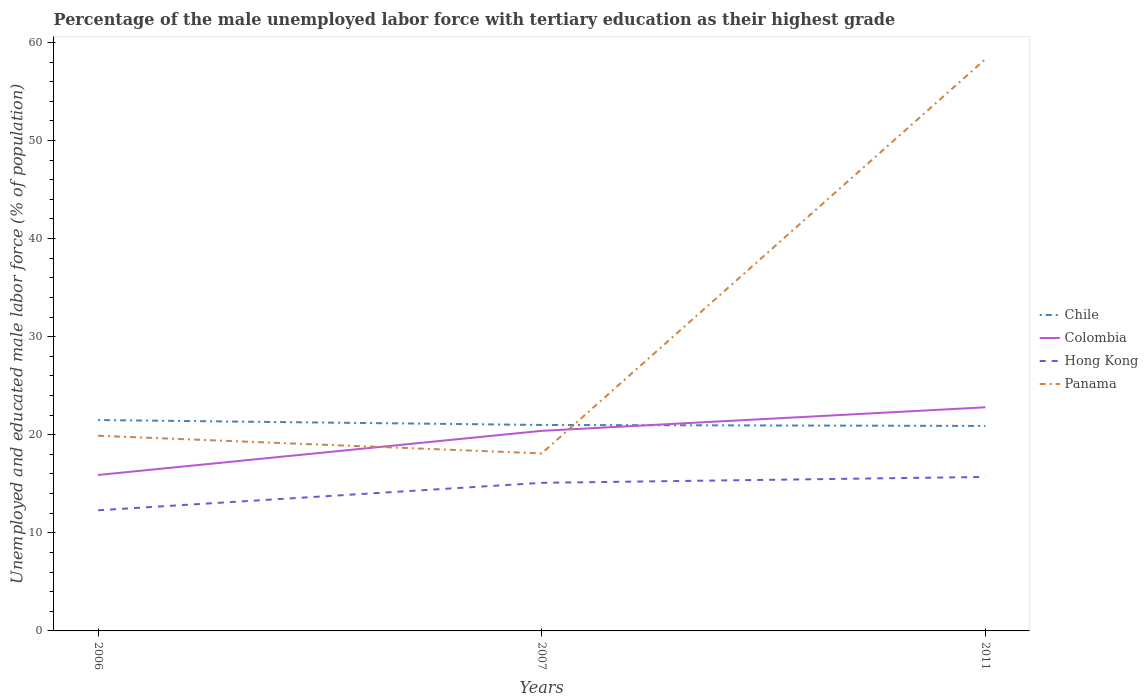Across all years, what is the maximum percentage of the unemployed male labor force with tertiary education in Panama?
Offer a terse response. 18.1. In which year was the percentage of the unemployed male labor force with tertiary education in Colombia maximum?
Provide a succinct answer. 2006. What is the total percentage of the unemployed male labor force with tertiary education in Hong Kong in the graph?
Ensure brevity in your answer.  -3.4. What is the difference between the highest and the second highest percentage of the unemployed male labor force with tertiary education in Hong Kong?
Offer a very short reply. 3.4. How many lines are there?
Provide a short and direct response. 4. What is the difference between two consecutive major ticks on the Y-axis?
Keep it short and to the point. 10. Does the graph contain any zero values?
Make the answer very short. No. How many legend labels are there?
Your response must be concise. 4. How are the legend labels stacked?
Offer a terse response. Vertical. What is the title of the graph?
Offer a terse response. Percentage of the male unemployed labor force with tertiary education as their highest grade. Does "Germany" appear as one of the legend labels in the graph?
Your answer should be compact. No. What is the label or title of the X-axis?
Ensure brevity in your answer.  Years. What is the label or title of the Y-axis?
Provide a short and direct response. Unemployed and educated male labor force (% of population). What is the Unemployed and educated male labor force (% of population) of Chile in 2006?
Your answer should be compact. 21.5. What is the Unemployed and educated male labor force (% of population) of Colombia in 2006?
Keep it short and to the point. 15.9. What is the Unemployed and educated male labor force (% of population) in Hong Kong in 2006?
Ensure brevity in your answer.  12.3. What is the Unemployed and educated male labor force (% of population) in Panama in 2006?
Offer a terse response. 19.9. What is the Unemployed and educated male labor force (% of population) in Colombia in 2007?
Your response must be concise. 20.4. What is the Unemployed and educated male labor force (% of population) of Hong Kong in 2007?
Offer a very short reply. 15.1. What is the Unemployed and educated male labor force (% of population) in Panama in 2007?
Provide a succinct answer. 18.1. What is the Unemployed and educated male labor force (% of population) in Chile in 2011?
Offer a very short reply. 20.9. What is the Unemployed and educated male labor force (% of population) in Colombia in 2011?
Give a very brief answer. 22.8. What is the Unemployed and educated male labor force (% of population) in Hong Kong in 2011?
Your response must be concise. 15.7. What is the Unemployed and educated male labor force (% of population) of Panama in 2011?
Offer a very short reply. 58.3. Across all years, what is the maximum Unemployed and educated male labor force (% of population) in Colombia?
Give a very brief answer. 22.8. Across all years, what is the maximum Unemployed and educated male labor force (% of population) of Hong Kong?
Make the answer very short. 15.7. Across all years, what is the maximum Unemployed and educated male labor force (% of population) in Panama?
Your answer should be very brief. 58.3. Across all years, what is the minimum Unemployed and educated male labor force (% of population) of Chile?
Your answer should be very brief. 20.9. Across all years, what is the minimum Unemployed and educated male labor force (% of population) in Colombia?
Provide a succinct answer. 15.9. Across all years, what is the minimum Unemployed and educated male labor force (% of population) of Hong Kong?
Provide a short and direct response. 12.3. Across all years, what is the minimum Unemployed and educated male labor force (% of population) of Panama?
Provide a succinct answer. 18.1. What is the total Unemployed and educated male labor force (% of population) in Chile in the graph?
Your answer should be very brief. 63.4. What is the total Unemployed and educated male labor force (% of population) in Colombia in the graph?
Your answer should be very brief. 59.1. What is the total Unemployed and educated male labor force (% of population) of Hong Kong in the graph?
Your answer should be very brief. 43.1. What is the total Unemployed and educated male labor force (% of population) of Panama in the graph?
Offer a terse response. 96.3. What is the difference between the Unemployed and educated male labor force (% of population) of Chile in 2006 and that in 2007?
Make the answer very short. 0.5. What is the difference between the Unemployed and educated male labor force (% of population) in Colombia in 2006 and that in 2007?
Give a very brief answer. -4.5. What is the difference between the Unemployed and educated male labor force (% of population) in Hong Kong in 2006 and that in 2007?
Your answer should be compact. -2.8. What is the difference between the Unemployed and educated male labor force (% of population) in Panama in 2006 and that in 2007?
Your answer should be compact. 1.8. What is the difference between the Unemployed and educated male labor force (% of population) in Chile in 2006 and that in 2011?
Your answer should be very brief. 0.6. What is the difference between the Unemployed and educated male labor force (% of population) of Colombia in 2006 and that in 2011?
Provide a succinct answer. -6.9. What is the difference between the Unemployed and educated male labor force (% of population) in Panama in 2006 and that in 2011?
Provide a short and direct response. -38.4. What is the difference between the Unemployed and educated male labor force (% of population) in Colombia in 2007 and that in 2011?
Your answer should be very brief. -2.4. What is the difference between the Unemployed and educated male labor force (% of population) in Panama in 2007 and that in 2011?
Your response must be concise. -40.2. What is the difference between the Unemployed and educated male labor force (% of population) in Chile in 2006 and the Unemployed and educated male labor force (% of population) in Colombia in 2007?
Your response must be concise. 1.1. What is the difference between the Unemployed and educated male labor force (% of population) in Chile in 2006 and the Unemployed and educated male labor force (% of population) in Hong Kong in 2007?
Keep it short and to the point. 6.4. What is the difference between the Unemployed and educated male labor force (% of population) of Chile in 2006 and the Unemployed and educated male labor force (% of population) of Panama in 2007?
Keep it short and to the point. 3.4. What is the difference between the Unemployed and educated male labor force (% of population) of Colombia in 2006 and the Unemployed and educated male labor force (% of population) of Panama in 2007?
Offer a very short reply. -2.2. What is the difference between the Unemployed and educated male labor force (% of population) of Hong Kong in 2006 and the Unemployed and educated male labor force (% of population) of Panama in 2007?
Give a very brief answer. -5.8. What is the difference between the Unemployed and educated male labor force (% of population) of Chile in 2006 and the Unemployed and educated male labor force (% of population) of Colombia in 2011?
Ensure brevity in your answer.  -1.3. What is the difference between the Unemployed and educated male labor force (% of population) of Chile in 2006 and the Unemployed and educated male labor force (% of population) of Panama in 2011?
Provide a succinct answer. -36.8. What is the difference between the Unemployed and educated male labor force (% of population) in Colombia in 2006 and the Unemployed and educated male labor force (% of population) in Hong Kong in 2011?
Offer a very short reply. 0.2. What is the difference between the Unemployed and educated male labor force (% of population) of Colombia in 2006 and the Unemployed and educated male labor force (% of population) of Panama in 2011?
Your response must be concise. -42.4. What is the difference between the Unemployed and educated male labor force (% of population) in Hong Kong in 2006 and the Unemployed and educated male labor force (% of population) in Panama in 2011?
Make the answer very short. -46. What is the difference between the Unemployed and educated male labor force (% of population) in Chile in 2007 and the Unemployed and educated male labor force (% of population) in Colombia in 2011?
Make the answer very short. -1.8. What is the difference between the Unemployed and educated male labor force (% of population) of Chile in 2007 and the Unemployed and educated male labor force (% of population) of Hong Kong in 2011?
Your answer should be compact. 5.3. What is the difference between the Unemployed and educated male labor force (% of population) of Chile in 2007 and the Unemployed and educated male labor force (% of population) of Panama in 2011?
Provide a short and direct response. -37.3. What is the difference between the Unemployed and educated male labor force (% of population) of Colombia in 2007 and the Unemployed and educated male labor force (% of population) of Panama in 2011?
Offer a very short reply. -37.9. What is the difference between the Unemployed and educated male labor force (% of population) of Hong Kong in 2007 and the Unemployed and educated male labor force (% of population) of Panama in 2011?
Keep it short and to the point. -43.2. What is the average Unemployed and educated male labor force (% of population) of Chile per year?
Your answer should be very brief. 21.13. What is the average Unemployed and educated male labor force (% of population) in Hong Kong per year?
Provide a succinct answer. 14.37. What is the average Unemployed and educated male labor force (% of population) of Panama per year?
Provide a succinct answer. 32.1. In the year 2006, what is the difference between the Unemployed and educated male labor force (% of population) in Chile and Unemployed and educated male labor force (% of population) in Colombia?
Make the answer very short. 5.6. In the year 2006, what is the difference between the Unemployed and educated male labor force (% of population) of Chile and Unemployed and educated male labor force (% of population) of Panama?
Provide a short and direct response. 1.6. In the year 2006, what is the difference between the Unemployed and educated male labor force (% of population) in Colombia and Unemployed and educated male labor force (% of population) in Hong Kong?
Keep it short and to the point. 3.6. In the year 2006, what is the difference between the Unemployed and educated male labor force (% of population) of Hong Kong and Unemployed and educated male labor force (% of population) of Panama?
Your response must be concise. -7.6. In the year 2007, what is the difference between the Unemployed and educated male labor force (% of population) of Chile and Unemployed and educated male labor force (% of population) of Hong Kong?
Make the answer very short. 5.9. In the year 2007, what is the difference between the Unemployed and educated male labor force (% of population) of Colombia and Unemployed and educated male labor force (% of population) of Hong Kong?
Provide a succinct answer. 5.3. In the year 2011, what is the difference between the Unemployed and educated male labor force (% of population) of Chile and Unemployed and educated male labor force (% of population) of Colombia?
Your answer should be compact. -1.9. In the year 2011, what is the difference between the Unemployed and educated male labor force (% of population) in Chile and Unemployed and educated male labor force (% of population) in Hong Kong?
Give a very brief answer. 5.2. In the year 2011, what is the difference between the Unemployed and educated male labor force (% of population) of Chile and Unemployed and educated male labor force (% of population) of Panama?
Offer a terse response. -37.4. In the year 2011, what is the difference between the Unemployed and educated male labor force (% of population) of Colombia and Unemployed and educated male labor force (% of population) of Hong Kong?
Give a very brief answer. 7.1. In the year 2011, what is the difference between the Unemployed and educated male labor force (% of population) of Colombia and Unemployed and educated male labor force (% of population) of Panama?
Provide a succinct answer. -35.5. In the year 2011, what is the difference between the Unemployed and educated male labor force (% of population) in Hong Kong and Unemployed and educated male labor force (% of population) in Panama?
Your answer should be very brief. -42.6. What is the ratio of the Unemployed and educated male labor force (% of population) in Chile in 2006 to that in 2007?
Give a very brief answer. 1.02. What is the ratio of the Unemployed and educated male labor force (% of population) of Colombia in 2006 to that in 2007?
Give a very brief answer. 0.78. What is the ratio of the Unemployed and educated male labor force (% of population) of Hong Kong in 2006 to that in 2007?
Your response must be concise. 0.81. What is the ratio of the Unemployed and educated male labor force (% of population) in Panama in 2006 to that in 2007?
Offer a very short reply. 1.1. What is the ratio of the Unemployed and educated male labor force (% of population) of Chile in 2006 to that in 2011?
Provide a succinct answer. 1.03. What is the ratio of the Unemployed and educated male labor force (% of population) in Colombia in 2006 to that in 2011?
Keep it short and to the point. 0.7. What is the ratio of the Unemployed and educated male labor force (% of population) of Hong Kong in 2006 to that in 2011?
Provide a succinct answer. 0.78. What is the ratio of the Unemployed and educated male labor force (% of population) in Panama in 2006 to that in 2011?
Make the answer very short. 0.34. What is the ratio of the Unemployed and educated male labor force (% of population) in Colombia in 2007 to that in 2011?
Your answer should be very brief. 0.89. What is the ratio of the Unemployed and educated male labor force (% of population) in Hong Kong in 2007 to that in 2011?
Ensure brevity in your answer.  0.96. What is the ratio of the Unemployed and educated male labor force (% of population) in Panama in 2007 to that in 2011?
Your response must be concise. 0.31. What is the difference between the highest and the second highest Unemployed and educated male labor force (% of population) of Colombia?
Keep it short and to the point. 2.4. What is the difference between the highest and the second highest Unemployed and educated male labor force (% of population) in Hong Kong?
Make the answer very short. 0.6. What is the difference between the highest and the second highest Unemployed and educated male labor force (% of population) of Panama?
Provide a short and direct response. 38.4. What is the difference between the highest and the lowest Unemployed and educated male labor force (% of population) of Chile?
Offer a terse response. 0.6. What is the difference between the highest and the lowest Unemployed and educated male labor force (% of population) of Colombia?
Provide a succinct answer. 6.9. What is the difference between the highest and the lowest Unemployed and educated male labor force (% of population) in Panama?
Offer a very short reply. 40.2. 